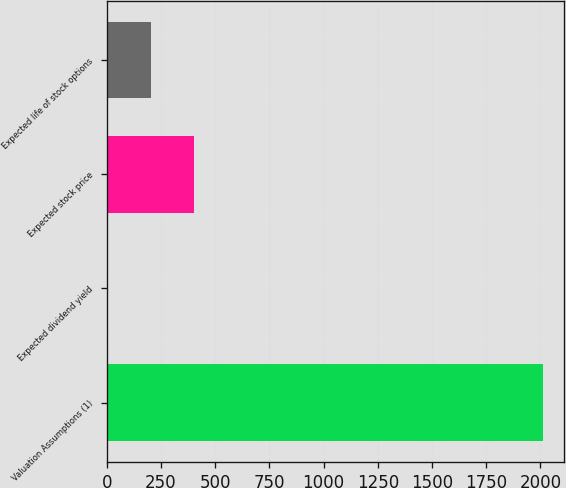Convert chart. <chart><loc_0><loc_0><loc_500><loc_500><bar_chart><fcel>Valuation Assumptions (1)<fcel>Expected dividend yield<fcel>Expected stock price<fcel>Expected life of stock options<nl><fcel>2010<fcel>1.6<fcel>403.28<fcel>202.44<nl></chart> 